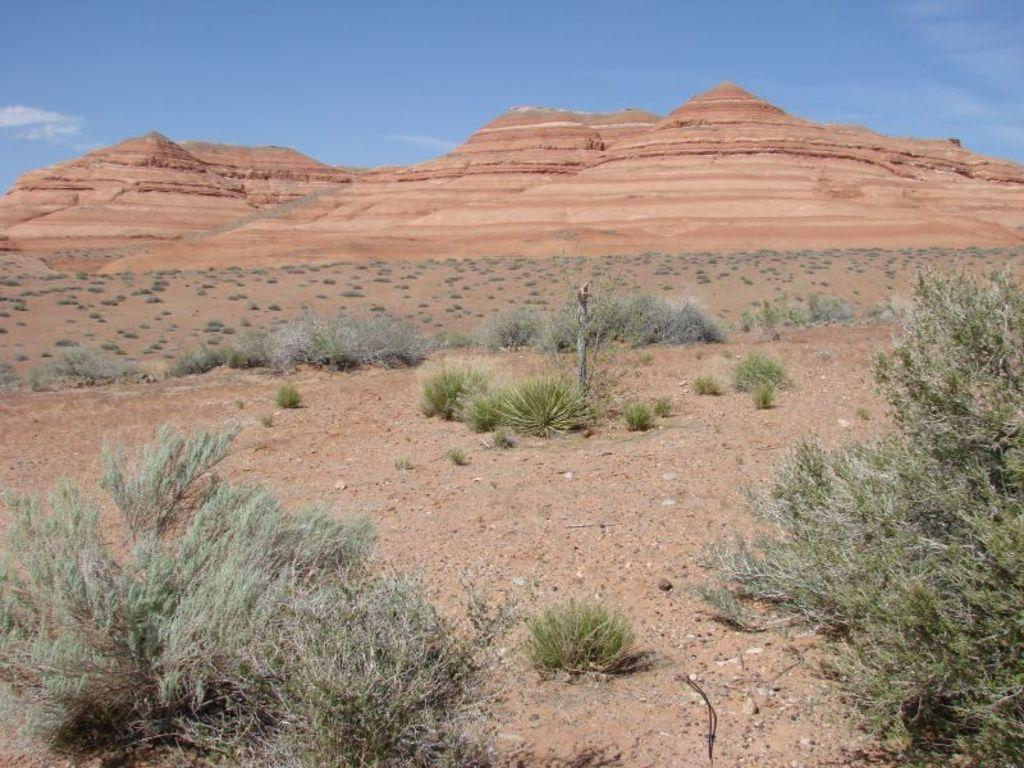What type of geological feature is present in the image? There are rock formation cliffs in the image. What type of vegetation can be seen in the image? There is grass and plants in the image. What type of terrain is visible in the image? There is sand in the image. What is visible in the sky in the image? There are clouds in the sky in the image. Can you see any friends riding a train on the cliffs in the image? There are no friends or trains present in the image; it features rock formation cliffs, grass, plants, sand, and clouds. 